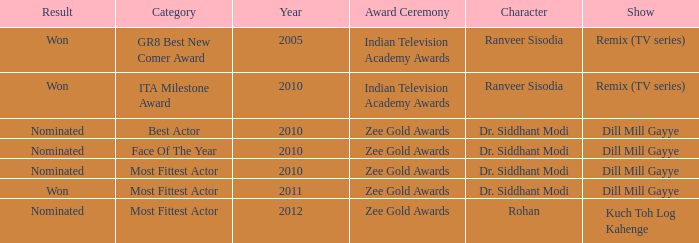Could you help me parse every detail presented in this table? {'header': ['Result', 'Category', 'Year', 'Award Ceremony', 'Character', 'Show'], 'rows': [['Won', 'GR8 Best New Comer Award', '2005', 'Indian Television Academy Awards', 'Ranveer Sisodia', 'Remix (TV series)'], ['Won', 'ITA Milestone Award', '2010', 'Indian Television Academy Awards', 'Ranveer Sisodia', 'Remix (TV series)'], ['Nominated', 'Best Actor', '2010', 'Zee Gold Awards', 'Dr. Siddhant Modi', 'Dill Mill Gayye'], ['Nominated', 'Face Of The Year', '2010', 'Zee Gold Awards', 'Dr. Siddhant Modi', 'Dill Mill Gayye'], ['Nominated', 'Most Fittest Actor', '2010', 'Zee Gold Awards', 'Dr. Siddhant Modi', 'Dill Mill Gayye'], ['Won', 'Most Fittest Actor', '2011', 'Zee Gold Awards', 'Dr. Siddhant Modi', 'Dill Mill Gayye'], ['Nominated', 'Most Fittest Actor', '2012', 'Zee Gold Awards', 'Rohan', 'Kuch Toh Log Kahenge']]} Which character was nominated in the 2010 indian television academy awards? Ranveer Sisodia. 